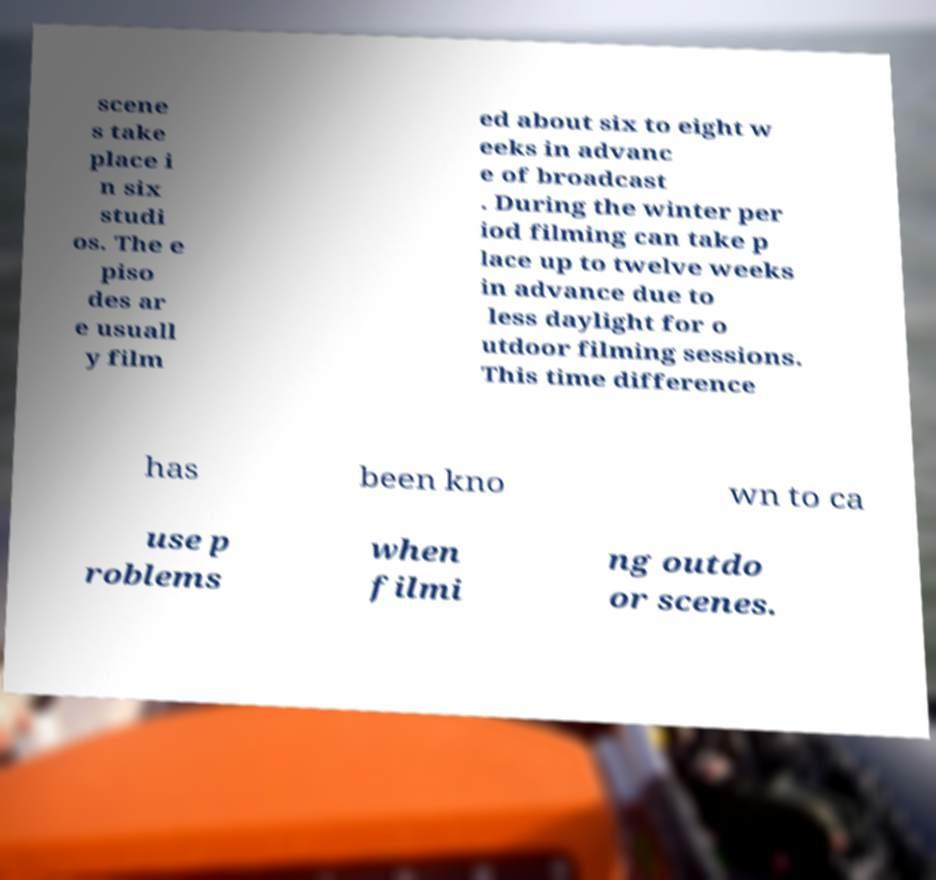Could you assist in decoding the text presented in this image and type it out clearly? scene s take place i n six studi os. The e piso des ar e usuall y film ed about six to eight w eeks in advanc e of broadcast . During the winter per iod filming can take p lace up to twelve weeks in advance due to less daylight for o utdoor filming sessions. This time difference has been kno wn to ca use p roblems when filmi ng outdo or scenes. 